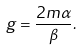<formula> <loc_0><loc_0><loc_500><loc_500>g = \frac { 2 m \alpha } { \beta } .</formula> 